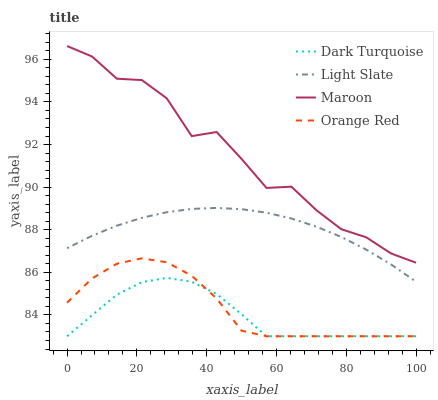Does Dark Turquoise have the minimum area under the curve?
Answer yes or no. Yes. Does Maroon have the maximum area under the curve?
Answer yes or no. Yes. Does Orange Red have the minimum area under the curve?
Answer yes or no. No. Does Orange Red have the maximum area under the curve?
Answer yes or no. No. Is Light Slate the smoothest?
Answer yes or no. Yes. Is Maroon the roughest?
Answer yes or no. Yes. Is Dark Turquoise the smoothest?
Answer yes or no. No. Is Dark Turquoise the roughest?
Answer yes or no. No. Does Maroon have the lowest value?
Answer yes or no. No. Does Maroon have the highest value?
Answer yes or no. Yes. Does Orange Red have the highest value?
Answer yes or no. No. Is Orange Red less than Maroon?
Answer yes or no. Yes. Is Maroon greater than Orange Red?
Answer yes or no. Yes. Does Dark Turquoise intersect Orange Red?
Answer yes or no. Yes. Is Dark Turquoise less than Orange Red?
Answer yes or no. No. Is Dark Turquoise greater than Orange Red?
Answer yes or no. No. Does Orange Red intersect Maroon?
Answer yes or no. No. 